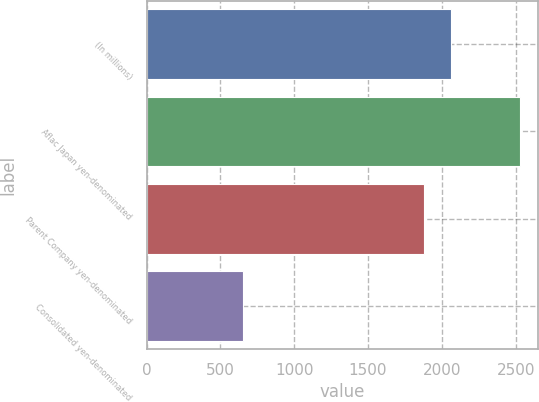<chart> <loc_0><loc_0><loc_500><loc_500><bar_chart><fcel>(In millions)<fcel>Aflac Japan yen-denominated<fcel>Parent Company yen-denominated<fcel>Consolidated yen-denominated<nl><fcel>2063.6<fcel>2528<fcel>1876<fcel>652<nl></chart> 